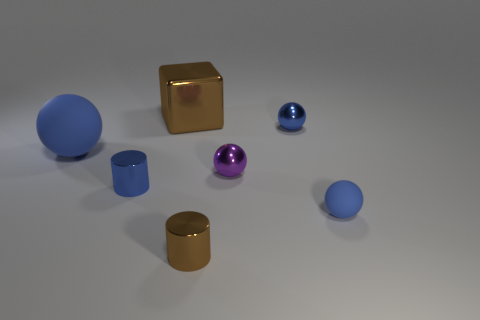Subtract all gray cylinders. How many blue balls are left? 3 Subtract 1 balls. How many balls are left? 3 Add 1 big balls. How many objects exist? 8 Subtract all balls. How many objects are left? 3 Subtract all purple metal spheres. Subtract all small metal objects. How many objects are left? 2 Add 6 purple things. How many purple things are left? 7 Add 6 small gray cubes. How many small gray cubes exist? 6 Subtract 0 purple blocks. How many objects are left? 7 